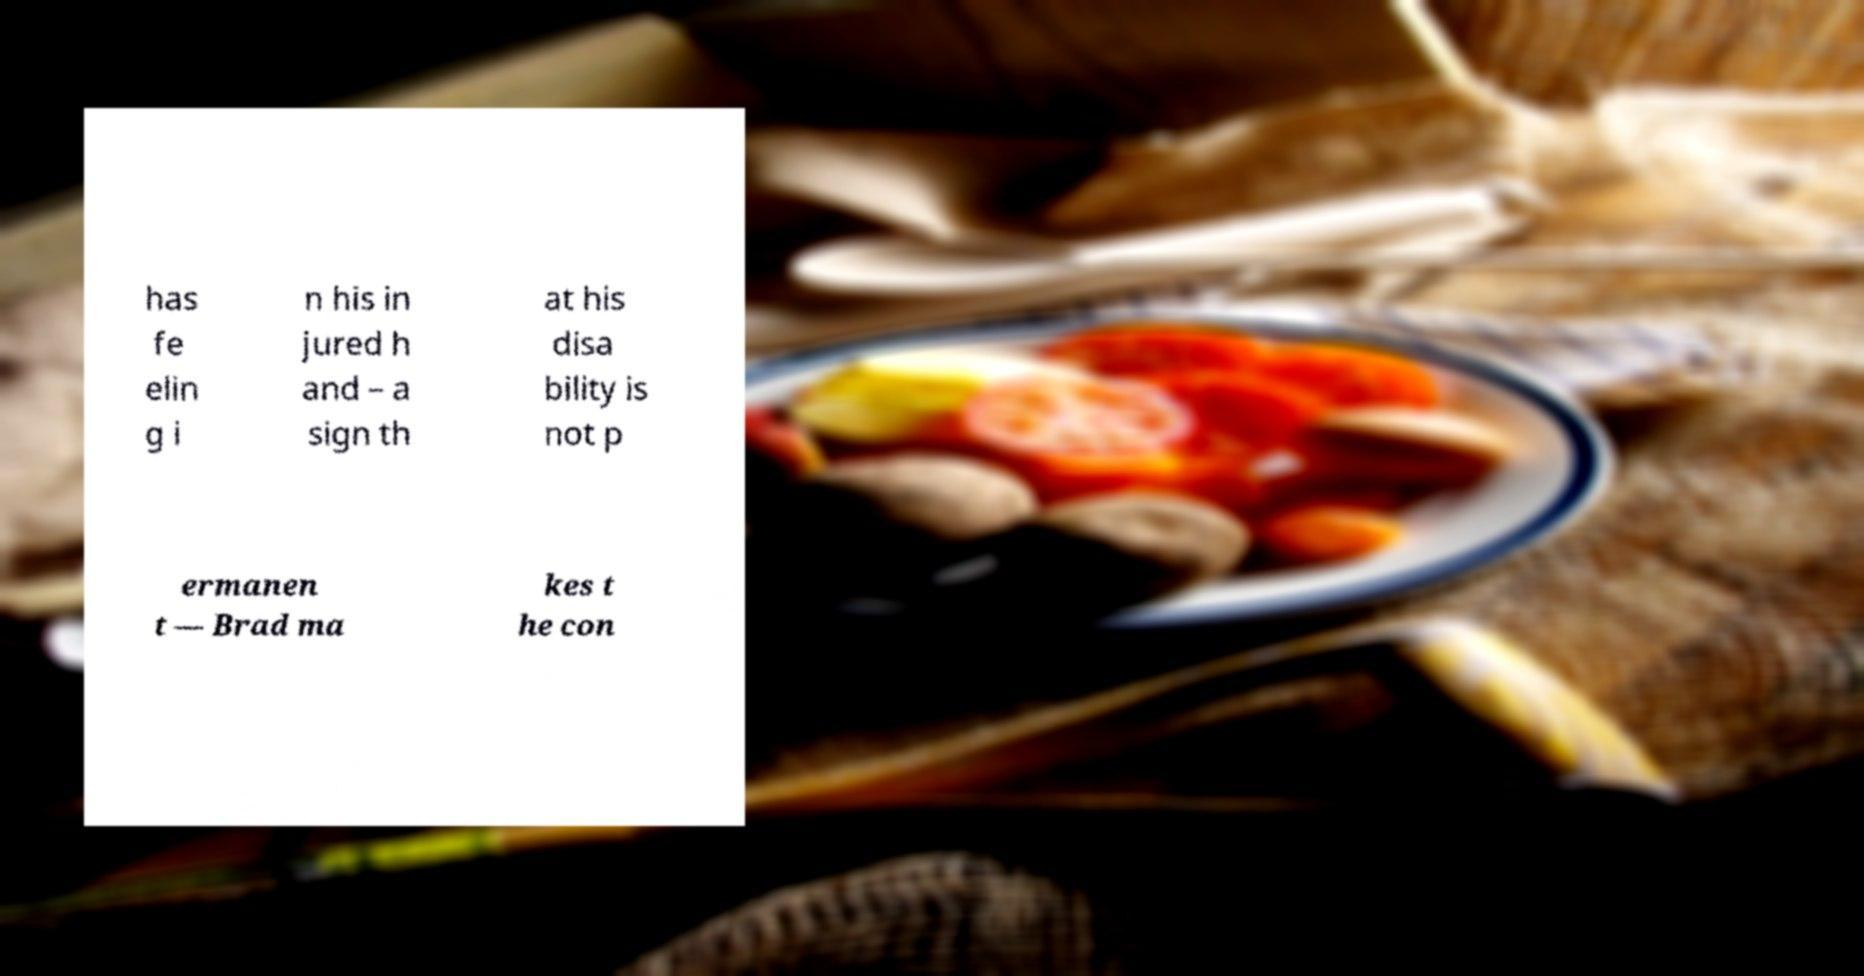Can you accurately transcribe the text from the provided image for me? has fe elin g i n his in jured h and – a sign th at his disa bility is not p ermanen t — Brad ma kes t he con 